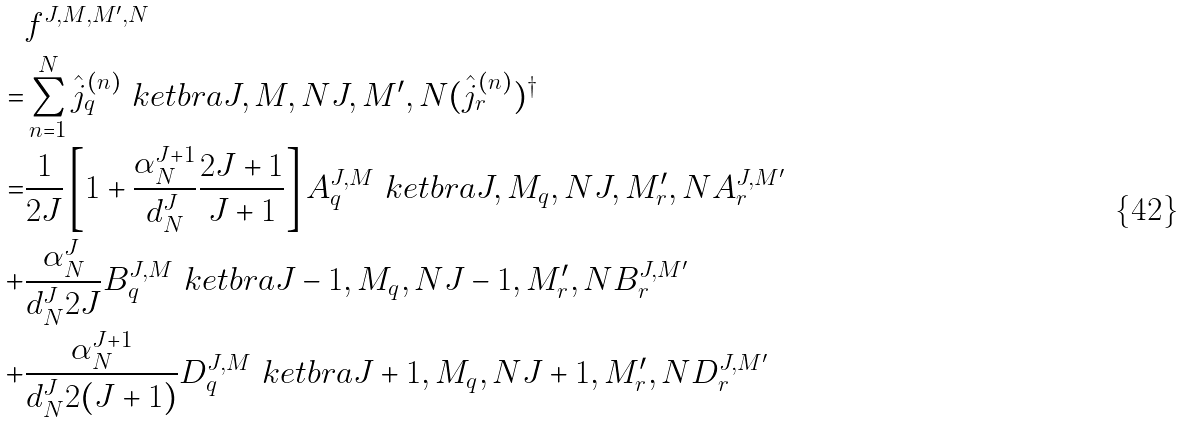<formula> <loc_0><loc_0><loc_500><loc_500>& f ^ { J , M , M ^ { \prime } , N } \\ = & \sum _ { n = 1 } ^ { N } \hat { j } _ { q } ^ { ( n ) } \ k e t b r a { J , M , N } { J , M ^ { \prime } , N } ( \hat { j } _ { r } ^ { ( n ) } ) ^ { \dagger } \\ = & \frac { 1 } { 2 J } \left [ 1 + \frac { \alpha ^ { J + 1 } _ { N } } { d ^ { J } _ { N } } \frac { 2 J + 1 } { J + 1 } \right ] A _ { q } ^ { J , M } \ k e t b r a { J , M _ { q } , N } { J , M ^ { \prime } _ { r } , N } A _ { r } ^ { J , M ^ { \prime } } \\ + & \frac { \alpha ^ { J } _ { N } } { d ^ { J } _ { N } 2 J } B _ { q } ^ { J , M } \ k e t b r a { J - 1 , M _ { q } , N } { J - 1 , M ^ { \prime } _ { r } , N } B _ { r } ^ { J , M ^ { \prime } } \\ + & \frac { \alpha ^ { J + 1 } _ { N } } { d ^ { J } _ { N } 2 ( J + 1 ) } D _ { q } ^ { J , M } \ k e t b r a { J + 1 , M _ { q } , N } { J + 1 , M ^ { \prime } _ { r } , N } D _ { r } ^ { J , M ^ { \prime } }</formula> 